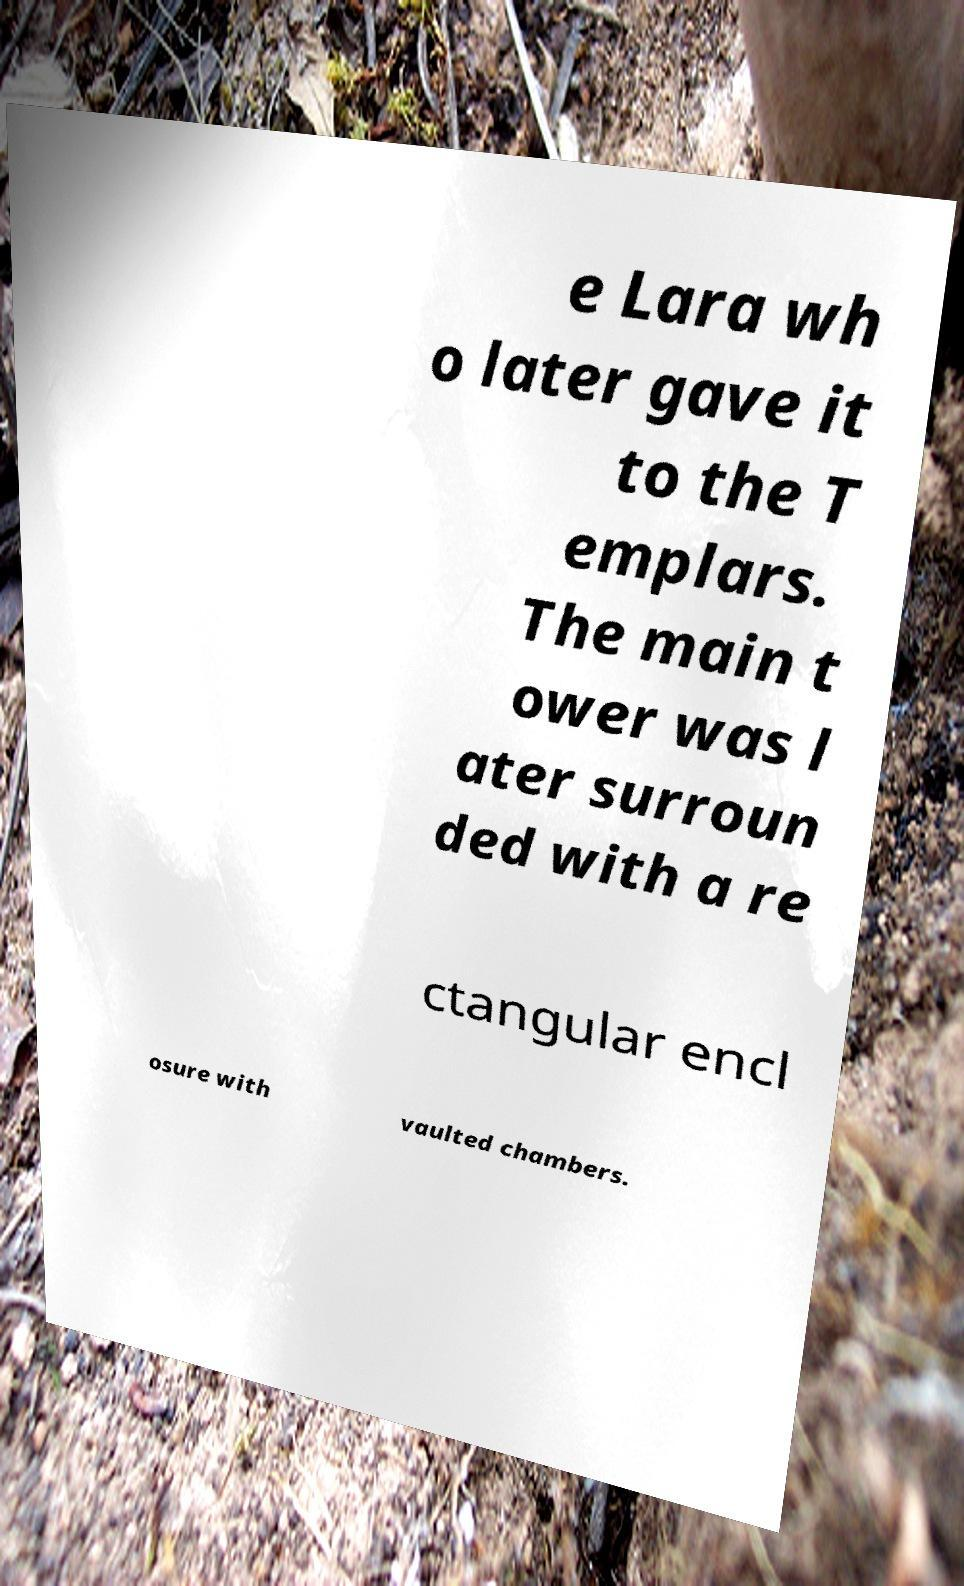I need the written content from this picture converted into text. Can you do that? e Lara wh o later gave it to the T emplars. The main t ower was l ater surroun ded with a re ctangular encl osure with vaulted chambers. 